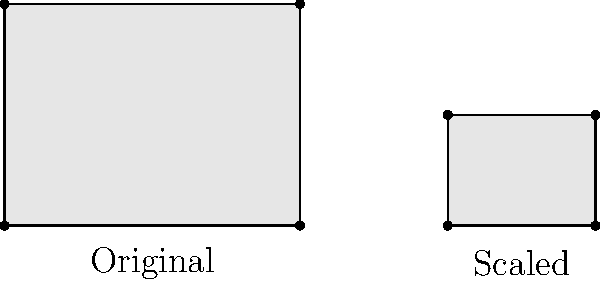In Van Dyck's group portraits, he often adjusted the scaling of figures to create a sense of depth and hierarchy. Consider the two rectangles above representing figures in a portrait. If the original figure (left) has dimensions 4 units by 3 units, and the scaled figure (right) has a width of 2 units, what is the height of the scaled figure to maintain the same proportions as the original? To solve this problem, we need to understand the concept of proportional scaling in transformational geometry. Let's approach this step-by-step:

1) First, let's identify the known dimensions:
   - Original figure: 4 units wide, 3 units tall
   - Scaled figure: 2 units wide, height unknown

2) The key principle here is that scaling should maintain the same proportion. This means the ratio of width to height should be the same for both figures.

3) Let's express this as an equation:
   $$\frac{\text{Original Width}}{\text{Original Height}} = \frac{\text{Scaled Width}}{\text{Scaled Height}}$$

4) Substituting the known values:
   $$\frac{4}{3} = \frac{2}{x}$$
   Where $x$ is the unknown height of the scaled figure.

5) To solve for $x$, we can cross-multiply:
   $$4x = 3 \cdot 2$$
   $$4x = 6$$

6) Dividing both sides by 4:
   $$x = \frac{6}{4} = 1.5$$

Therefore, to maintain the same proportions as the original figure, the scaled figure should have a height of 1.5 units.
Answer: 1.5 units 